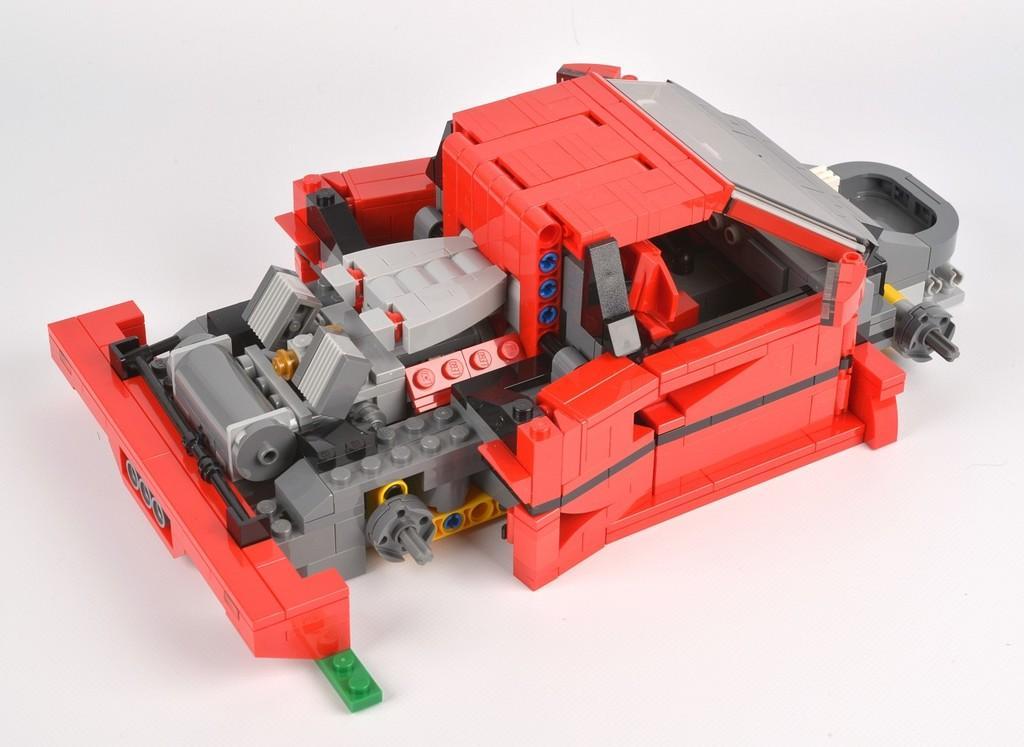In one or two sentences, can you explain what this image depicts? In this image I can see a toy which is made up of lego. I can see it is red, ash, black, yellow and green in color. I can see the white colored background. 